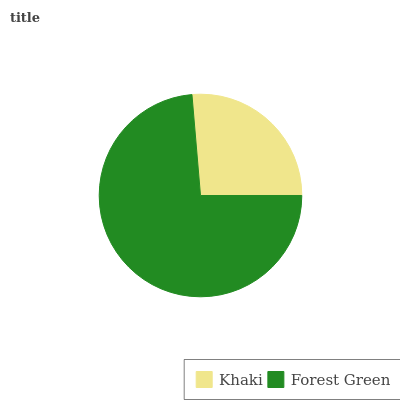Is Khaki the minimum?
Answer yes or no. Yes. Is Forest Green the maximum?
Answer yes or no. Yes. Is Forest Green the minimum?
Answer yes or no. No. Is Forest Green greater than Khaki?
Answer yes or no. Yes. Is Khaki less than Forest Green?
Answer yes or no. Yes. Is Khaki greater than Forest Green?
Answer yes or no. No. Is Forest Green less than Khaki?
Answer yes or no. No. Is Forest Green the high median?
Answer yes or no. Yes. Is Khaki the low median?
Answer yes or no. Yes. Is Khaki the high median?
Answer yes or no. No. Is Forest Green the low median?
Answer yes or no. No. 